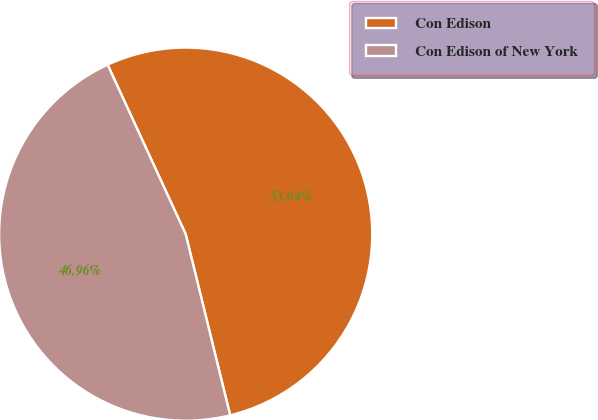Convert chart. <chart><loc_0><loc_0><loc_500><loc_500><pie_chart><fcel>Con Edison<fcel>Con Edison of New York<nl><fcel>53.04%<fcel>46.96%<nl></chart> 